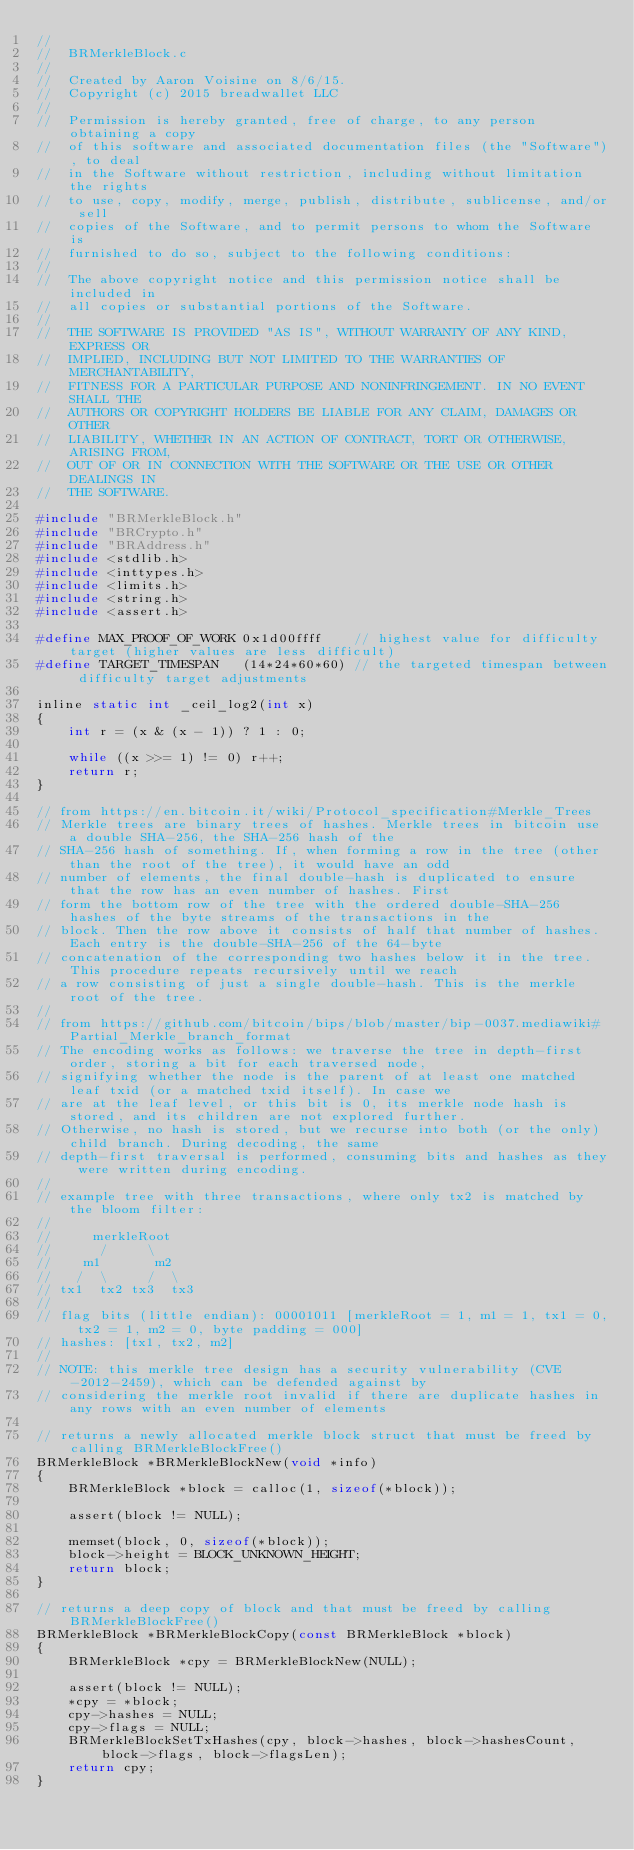Convert code to text. <code><loc_0><loc_0><loc_500><loc_500><_C_>//
//  BRMerkleBlock.c
//
//  Created by Aaron Voisine on 8/6/15.
//  Copyright (c) 2015 breadwallet LLC
//
//  Permission is hereby granted, free of charge, to any person obtaining a copy
//  of this software and associated documentation files (the "Software"), to deal
//  in the Software without restriction, including without limitation the rights
//  to use, copy, modify, merge, publish, distribute, sublicense, and/or sell
//  copies of the Software, and to permit persons to whom the Software is
//  furnished to do so, subject to the following conditions:
//
//  The above copyright notice and this permission notice shall be included in
//  all copies or substantial portions of the Software.
//
//  THE SOFTWARE IS PROVIDED "AS IS", WITHOUT WARRANTY OF ANY KIND, EXPRESS OR
//  IMPLIED, INCLUDING BUT NOT LIMITED TO THE WARRANTIES OF MERCHANTABILITY,
//  FITNESS FOR A PARTICULAR PURPOSE AND NONINFRINGEMENT. IN NO EVENT SHALL THE
//  AUTHORS OR COPYRIGHT HOLDERS BE LIABLE FOR ANY CLAIM, DAMAGES OR OTHER
//  LIABILITY, WHETHER IN AN ACTION OF CONTRACT, TORT OR OTHERWISE, ARISING FROM,
//  OUT OF OR IN CONNECTION WITH THE SOFTWARE OR THE USE OR OTHER DEALINGS IN
//  THE SOFTWARE.

#include "BRMerkleBlock.h"
#include "BRCrypto.h"
#include "BRAddress.h"
#include <stdlib.h>
#include <inttypes.h>
#include <limits.h>
#include <string.h>
#include <assert.h>

#define MAX_PROOF_OF_WORK 0x1d00ffff    // highest value for difficulty target (higher values are less difficult)
#define TARGET_TIMESPAN   (14*24*60*60) // the targeted timespan between difficulty target adjustments

inline static int _ceil_log2(int x)
{
    int r = (x & (x - 1)) ? 1 : 0;

    while ((x >>= 1) != 0) r++;
    return r;
}

// from https://en.bitcoin.it/wiki/Protocol_specification#Merkle_Trees
// Merkle trees are binary trees of hashes. Merkle trees in bitcoin use a double SHA-256, the SHA-256 hash of the
// SHA-256 hash of something. If, when forming a row in the tree (other than the root of the tree), it would have an odd
// number of elements, the final double-hash is duplicated to ensure that the row has an even number of hashes. First
// form the bottom row of the tree with the ordered double-SHA-256 hashes of the byte streams of the transactions in the
// block. Then the row above it consists of half that number of hashes. Each entry is the double-SHA-256 of the 64-byte
// concatenation of the corresponding two hashes below it in the tree. This procedure repeats recursively until we reach
// a row consisting of just a single double-hash. This is the merkle root of the tree.
//
// from https://github.com/bitcoin/bips/blob/master/bip-0037.mediawiki#Partial_Merkle_branch_format
// The encoding works as follows: we traverse the tree in depth-first order, storing a bit for each traversed node,
// signifying whether the node is the parent of at least one matched leaf txid (or a matched txid itself). In case we
// are at the leaf level, or this bit is 0, its merkle node hash is stored, and its children are not explored further.
// Otherwise, no hash is stored, but we recurse into both (or the only) child branch. During decoding, the same
// depth-first traversal is performed, consuming bits and hashes as they were written during encoding.
//
// example tree with three transactions, where only tx2 is matched by the bloom filter:
//
//     merkleRoot
//      /     \
//    m1       m2
//   /  \     /  \
// tx1  tx2 tx3  tx3
//
// flag bits (little endian): 00001011 [merkleRoot = 1, m1 = 1, tx1 = 0, tx2 = 1, m2 = 0, byte padding = 000]
// hashes: [tx1, tx2, m2]
//
// NOTE: this merkle tree design has a security vulnerability (CVE-2012-2459), which can be defended against by
// considering the merkle root invalid if there are duplicate hashes in any rows with an even number of elements

// returns a newly allocated merkle block struct that must be freed by calling BRMerkleBlockFree()
BRMerkleBlock *BRMerkleBlockNew(void *info)
{
	BRMerkleBlock *block = calloc(1, sizeof(*block));

	assert(block != NULL);

	memset(block, 0, sizeof(*block));
	block->height = BLOCK_UNKNOWN_HEIGHT;
	return block;
}

// returns a deep copy of block and that must be freed by calling BRMerkleBlockFree()
BRMerkleBlock *BRMerkleBlockCopy(const BRMerkleBlock *block)
{
    BRMerkleBlock *cpy = BRMerkleBlockNew(NULL);

    assert(block != NULL);
    *cpy = *block;
    cpy->hashes = NULL;
    cpy->flags = NULL;
    BRMerkleBlockSetTxHashes(cpy, block->hashes, block->hashesCount, block->flags, block->flagsLen);
    return cpy;
}
</code> 